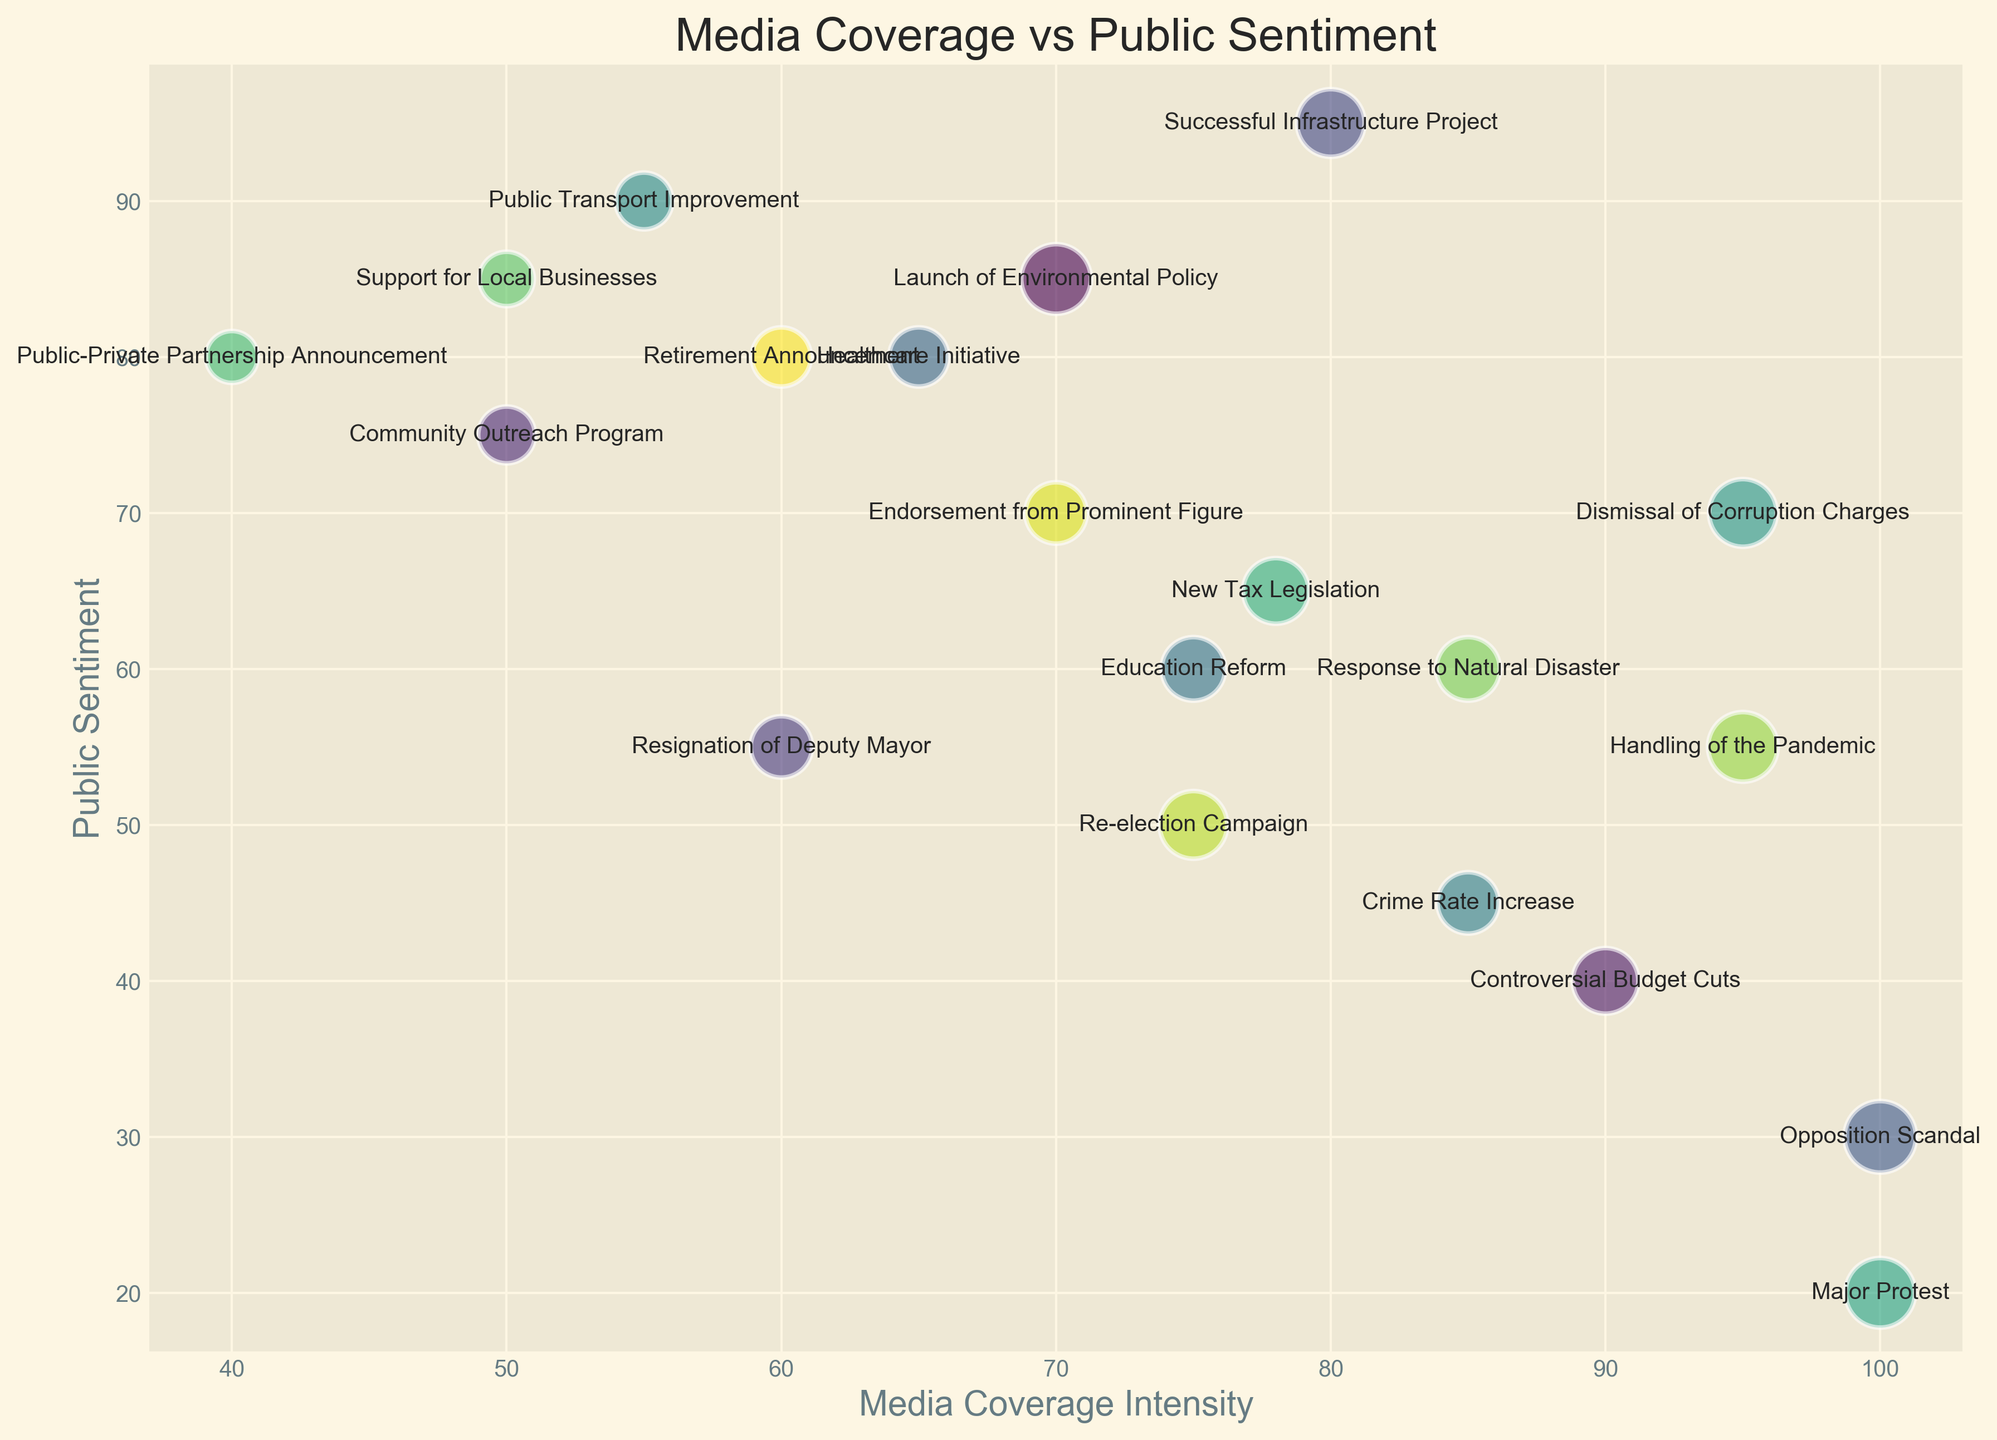What event had the highest public sentiment? Identify the bubble with the highest "Public Sentiment" value on the y-axis, then check the corresponding event label.
Answer: Successful Infrastructure Project Which event experienced the most intense media coverage? Locate the bubble farthest to the right on the x-axis, indicating the highest "Media Coverage Intensity," and note the event.
Answer: Major Protest What is the difference in public sentiment between the Launch of Environmental Policy and the Opposition Scandal? Find the "Public Sentiment" values for both events and subtract the smaller from the larger: 85 (Launch of Environmental Policy) - 30 (Opposition Scandal).
Answer: 55 Which event has a larger bubble size: Resignation of Deputy Mayor or Handling of the Pandemic? Compare the sizes of the bubbles for the two events. The event with the larger bubble size indicates a higher "ImpactScore."
Answer: Handling of the Pandemic What is the average public sentiment of the events with media coverage intensity greater than 90? Identify events with "Media Coverage Intensity" values over 90 (Opposition Scandal, Dismissal of Corruption Charges, and Major Protest) and compute the average of their "Public Sentiment" values: (30 + 70 + 20) / 3.
Answer: 40 Which event shows both high media coverage intensity and high public sentiment? Look for bubbles positioned high on the y-axis (indicating high "Public Sentiment") and far to the right on the x-axis (indicating high "Media Coverage Intensity"). The "Public Transport Improvement" event stands out.
Answer: Public Transport Improvement Is the media coverage intensity for the Re-election Campaign higher or lower than the Response to Natural Disaster? Compare the "Media Coverage Intensity" values of the two events: 75 (Re-election Campaign) vs. 85 (Response to Natural Disaster).
Answer: Lower Which event with a public sentiment above 80 had the most media coverage? Identify events with "Public Sentiment" greater than 80 (Launch of Environmental Policy, Successful Infrastructure Project, Public Transport Improvement, Support for Local Businesses), then find the event with the highest "Media Coverage Intensity" in this set.
Answer: Launch of Environmental Policy What is the median public sentiment of all events visualized? Sort all "Public Sentiment" values, then find the middle value in the sorted list: (85, 85, 90, 55, 95, 30, 80, 60, 45, 90, 70, 20, 65, 80, 85, 60, 55, 70, 80). The median is the 10th value.
Answer: 70 